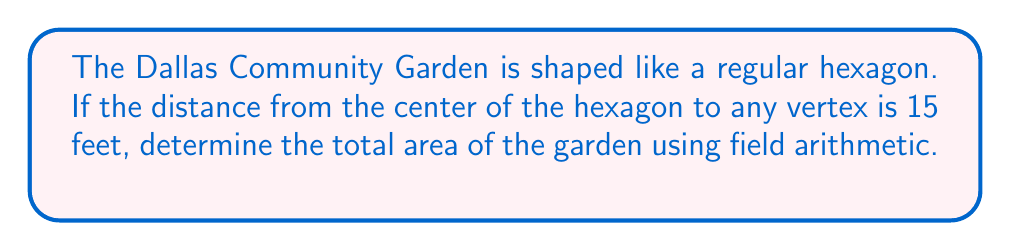What is the answer to this math problem? Let's approach this step-by-step using field arithmetic:

1) In a regular hexagon, we can divide it into six equilateral triangles.

2) The area of the hexagon will be 6 times the area of one equilateral triangle.

3) For an equilateral triangle with side length $a$, the area is given by:

   $$A_{\text{triangle}} = \frac{\sqrt{3}}{4}a^2$$

4) In our case, we're given the distance from the center to a vertex, which is the radius $r$ of the circumscribed circle. We need to find the side length $a$.

5) In a regular hexagon, $a = r\sqrt{3}$. So, $a = 15\sqrt{3}$ feet.

6) Now we can calculate the area of one triangle:

   $$A_{\text{triangle}} = \frac{\sqrt{3}}{4}(15\sqrt{3})^2 = \frac{\sqrt{3}}{4} \cdot 675 = \frac{675\sqrt{3}}{4}$$

7) The total area of the hexagon is 6 times this:

   $$A_{\text{hexagon}} = 6 \cdot \frac{675\sqrt{3}}{4} = \frac{1012.5\sqrt{3}}{1}$$

8) Simplifying: $A_{\text{hexagon}} = 1012.5\sqrt{3} \approx 1754.5$ square feet.
Answer: $1012.5\sqrt{3}$ sq ft 